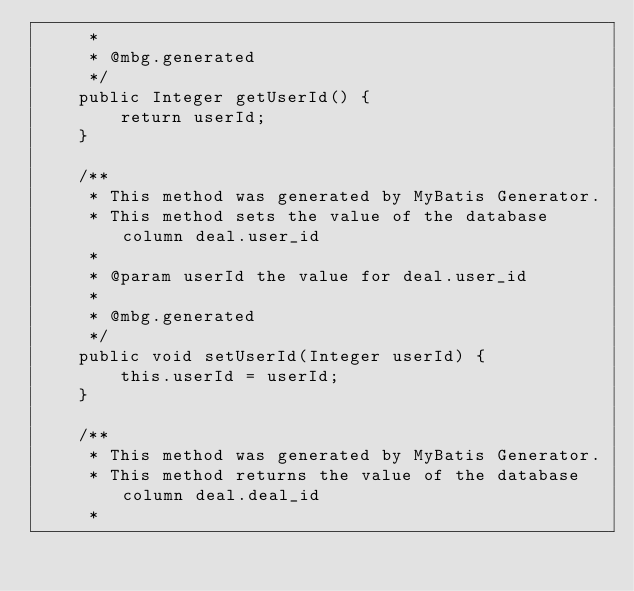<code> <loc_0><loc_0><loc_500><loc_500><_Java_>     *
     * @mbg.generated
     */
    public Integer getUserId() {
        return userId;
    }

    /**
     * This method was generated by MyBatis Generator.
     * This method sets the value of the database column deal.user_id
     *
     * @param userId the value for deal.user_id
     *
     * @mbg.generated
     */
    public void setUserId(Integer userId) {
        this.userId = userId;
    }

    /**
     * This method was generated by MyBatis Generator.
     * This method returns the value of the database column deal.deal_id
     *</code> 